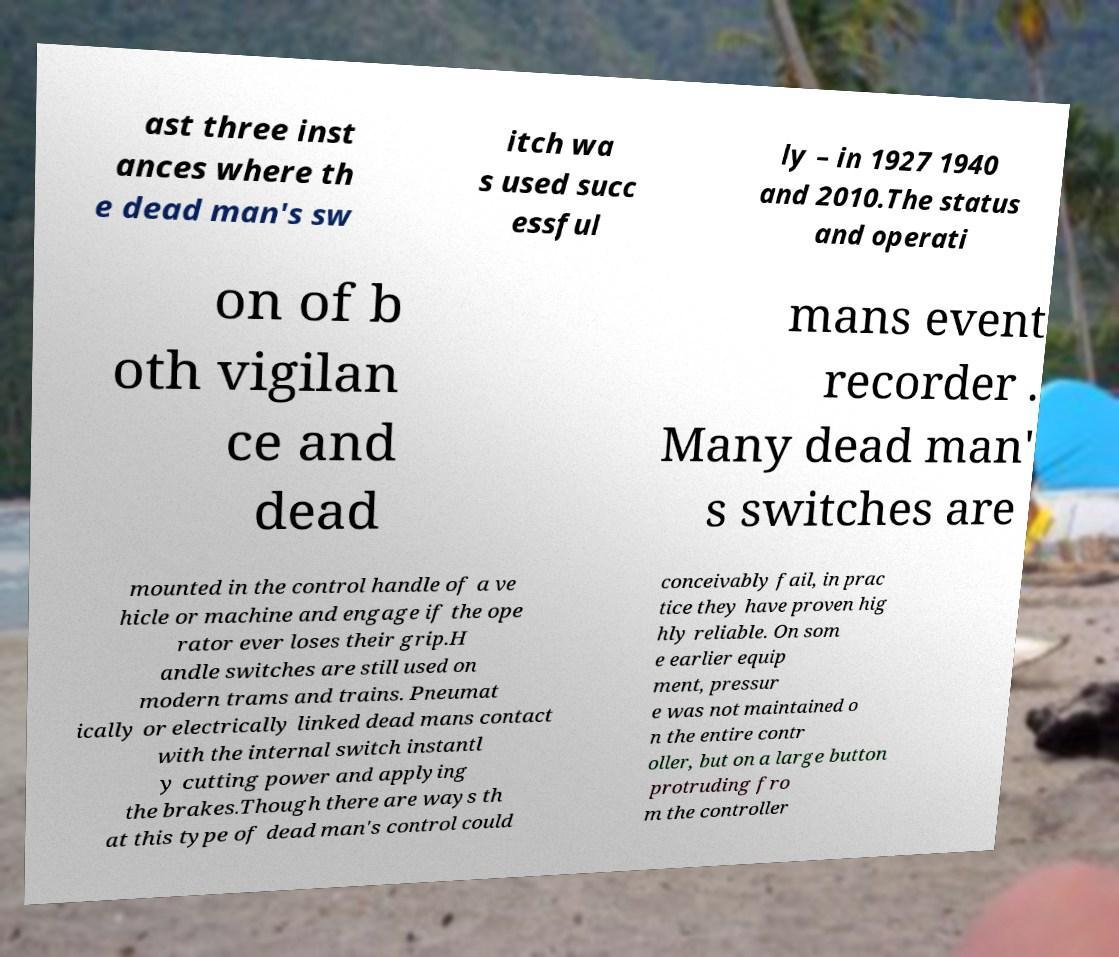Can you accurately transcribe the text from the provided image for me? ast three inst ances where th e dead man's sw itch wa s used succ essful ly – in 1927 1940 and 2010.The status and operati on of b oth vigilan ce and dead mans event recorder . Many dead man' s switches are mounted in the control handle of a ve hicle or machine and engage if the ope rator ever loses their grip.H andle switches are still used on modern trams and trains. Pneumat ically or electrically linked dead mans contact with the internal switch instantl y cutting power and applying the brakes.Though there are ways th at this type of dead man's control could conceivably fail, in prac tice they have proven hig hly reliable. On som e earlier equip ment, pressur e was not maintained o n the entire contr oller, but on a large button protruding fro m the controller 